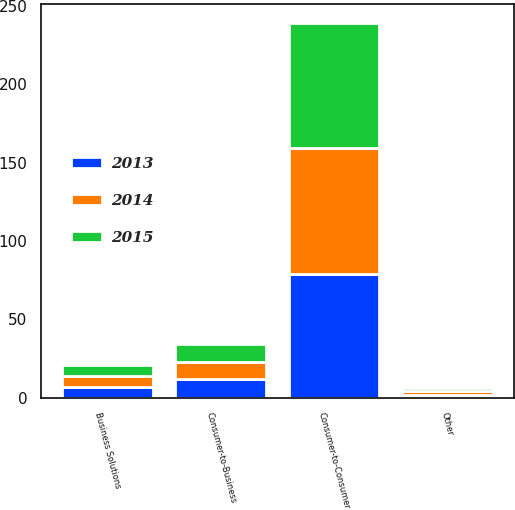Convert chart. <chart><loc_0><loc_0><loc_500><loc_500><stacked_bar_chart><ecel><fcel>Consumer-to-Consumer<fcel>Consumer-to-Business<fcel>Business Solutions<fcel>Other<nl><fcel>2013<fcel>79<fcel>12<fcel>7<fcel>2<nl><fcel>2015<fcel>80<fcel>11<fcel>7<fcel>2<nl><fcel>2014<fcel>80<fcel>11<fcel>7<fcel>2<nl></chart> 